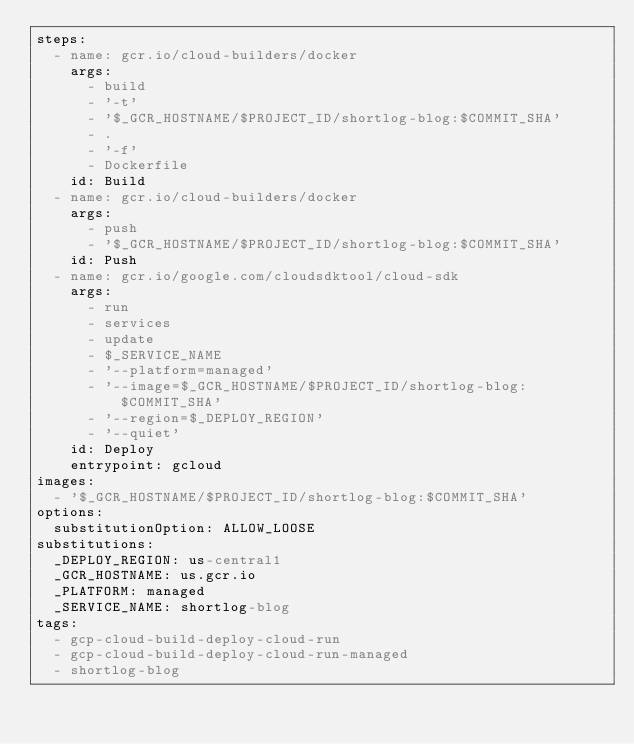Convert code to text. <code><loc_0><loc_0><loc_500><loc_500><_YAML_>steps:
  - name: gcr.io/cloud-builders/docker
    args:
      - build
      - '-t'
      - '$_GCR_HOSTNAME/$PROJECT_ID/shortlog-blog:$COMMIT_SHA'
      - .
      - '-f'
      - Dockerfile
    id: Build
  - name: gcr.io/cloud-builders/docker
    args:
      - push
      - '$_GCR_HOSTNAME/$PROJECT_ID/shortlog-blog:$COMMIT_SHA'
    id: Push
  - name: gcr.io/google.com/cloudsdktool/cloud-sdk
    args:
      - run
      - services
      - update
      - $_SERVICE_NAME
      - '--platform=managed'
      - '--image=$_GCR_HOSTNAME/$PROJECT_ID/shortlog-blog:$COMMIT_SHA'
      - '--region=$_DEPLOY_REGION'
      - '--quiet'
    id: Deploy
    entrypoint: gcloud
images:
  - '$_GCR_HOSTNAME/$PROJECT_ID/shortlog-blog:$COMMIT_SHA'
options:
  substitutionOption: ALLOW_LOOSE
substitutions:
  _DEPLOY_REGION: us-central1
  _GCR_HOSTNAME: us.gcr.io
  _PLATFORM: managed
  _SERVICE_NAME: shortlog-blog
tags:
  - gcp-cloud-build-deploy-cloud-run
  - gcp-cloud-build-deploy-cloud-run-managed
  - shortlog-blog
</code> 